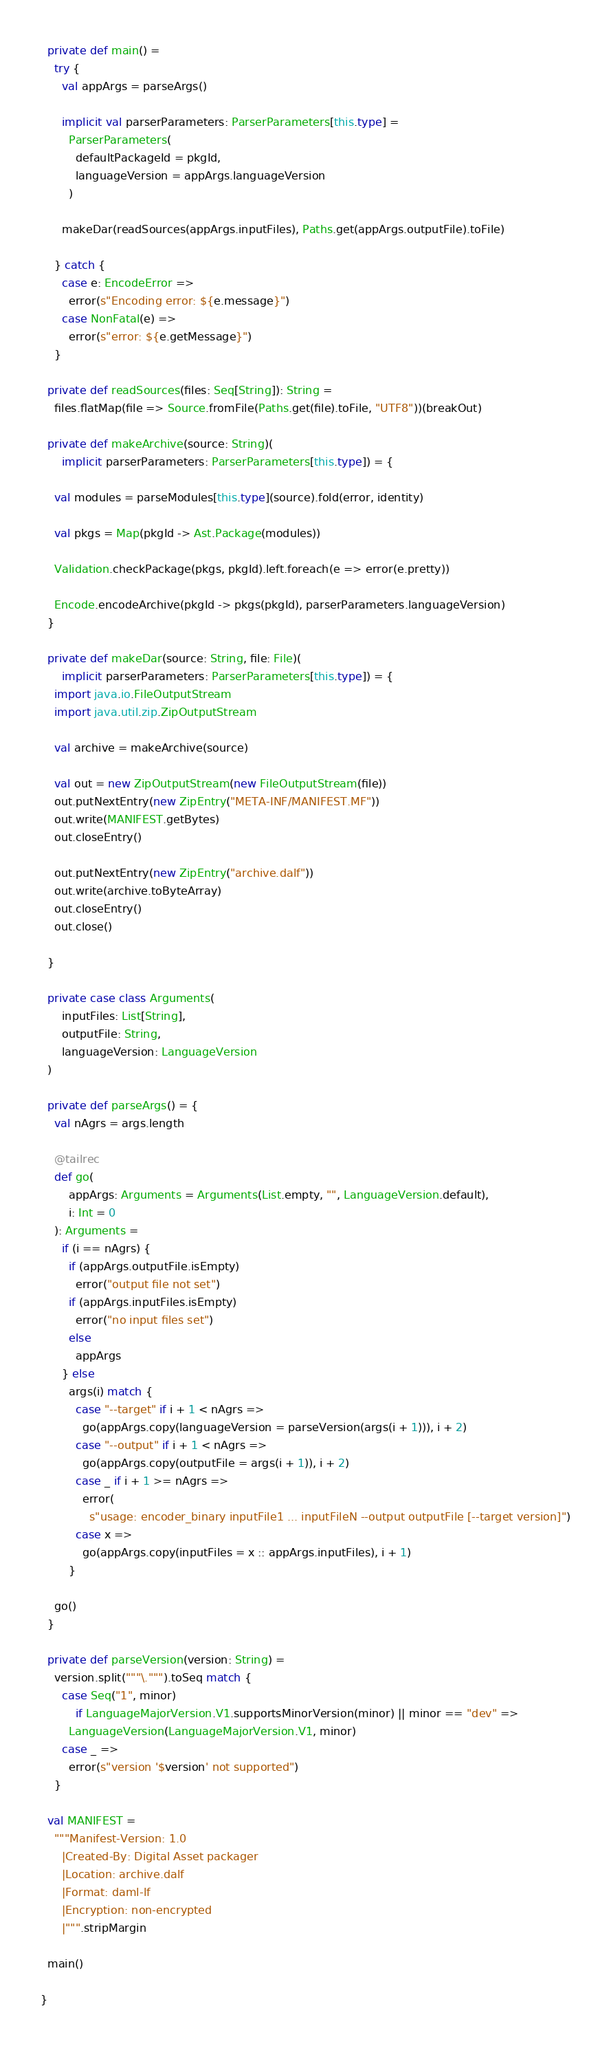<code> <loc_0><loc_0><loc_500><loc_500><_Scala_>
  private def main() =
    try {
      val appArgs = parseArgs()

      implicit val parserParameters: ParserParameters[this.type] =
        ParserParameters(
          defaultPackageId = pkgId,
          languageVersion = appArgs.languageVersion
        )

      makeDar(readSources(appArgs.inputFiles), Paths.get(appArgs.outputFile).toFile)

    } catch {
      case e: EncodeError =>
        error(s"Encoding error: ${e.message}")
      case NonFatal(e) =>
        error(s"error: ${e.getMessage}")
    }

  private def readSources(files: Seq[String]): String =
    files.flatMap(file => Source.fromFile(Paths.get(file).toFile, "UTF8"))(breakOut)

  private def makeArchive(source: String)(
      implicit parserParameters: ParserParameters[this.type]) = {

    val modules = parseModules[this.type](source).fold(error, identity)

    val pkgs = Map(pkgId -> Ast.Package(modules))

    Validation.checkPackage(pkgs, pkgId).left.foreach(e => error(e.pretty))

    Encode.encodeArchive(pkgId -> pkgs(pkgId), parserParameters.languageVersion)
  }

  private def makeDar(source: String, file: File)(
      implicit parserParameters: ParserParameters[this.type]) = {
    import java.io.FileOutputStream
    import java.util.zip.ZipOutputStream

    val archive = makeArchive(source)

    val out = new ZipOutputStream(new FileOutputStream(file))
    out.putNextEntry(new ZipEntry("META-INF/MANIFEST.MF"))
    out.write(MANIFEST.getBytes)
    out.closeEntry()

    out.putNextEntry(new ZipEntry("archive.dalf"))
    out.write(archive.toByteArray)
    out.closeEntry()
    out.close()

  }

  private case class Arguments(
      inputFiles: List[String],
      outputFile: String,
      languageVersion: LanguageVersion
  )

  private def parseArgs() = {
    val nAgrs = args.length

    @tailrec
    def go(
        appArgs: Arguments = Arguments(List.empty, "", LanguageVersion.default),
        i: Int = 0
    ): Arguments =
      if (i == nAgrs) {
        if (appArgs.outputFile.isEmpty)
          error("output file not set")
        if (appArgs.inputFiles.isEmpty)
          error("no input files set")
        else
          appArgs
      } else
        args(i) match {
          case "--target" if i + 1 < nAgrs =>
            go(appArgs.copy(languageVersion = parseVersion(args(i + 1))), i + 2)
          case "--output" if i + 1 < nAgrs =>
            go(appArgs.copy(outputFile = args(i + 1)), i + 2)
          case _ if i + 1 >= nAgrs =>
            error(
              s"usage: encoder_binary inputFile1 ... inputFileN --output outputFile [--target version]")
          case x =>
            go(appArgs.copy(inputFiles = x :: appArgs.inputFiles), i + 1)
        }

    go()
  }

  private def parseVersion(version: String) =
    version.split("""\.""").toSeq match {
      case Seq("1", minor)
          if LanguageMajorVersion.V1.supportsMinorVersion(minor) || minor == "dev" =>
        LanguageVersion(LanguageMajorVersion.V1, minor)
      case _ =>
        error(s"version '$version' not supported")
    }

  val MANIFEST =
    """Manifest-Version: 1.0
      |Created-By: Digital Asset packager
      |Location: archive.dalf
      |Format: daml-lf
      |Encryption: non-encrypted
      |""".stripMargin

  main()

}
</code> 